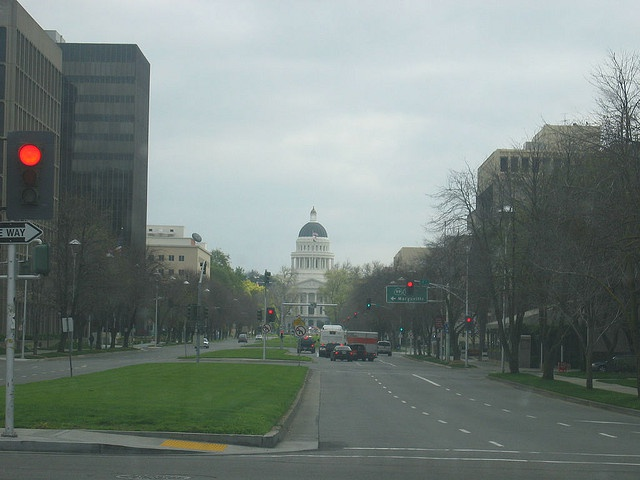Describe the objects in this image and their specific colors. I can see traffic light in gray, black, purple, and red tones, bus in gray, darkgray, black, and purple tones, car in gray, black, and purple tones, truck in gray, maroon, and black tones, and car in gray, black, purple, and darkgray tones in this image. 